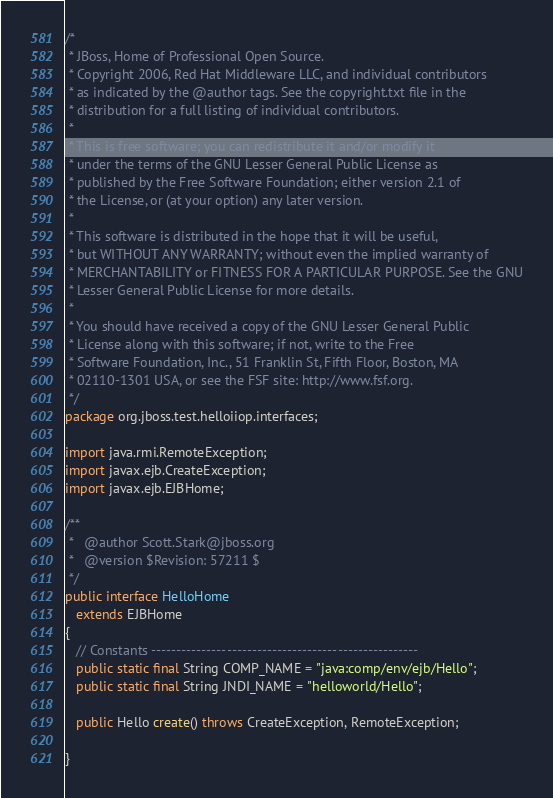Convert code to text. <code><loc_0><loc_0><loc_500><loc_500><_Java_>/*
 * JBoss, Home of Professional Open Source.
 * Copyright 2006, Red Hat Middleware LLC, and individual contributors
 * as indicated by the @author tags. See the copyright.txt file in the
 * distribution for a full listing of individual contributors.
 *
 * This is free software; you can redistribute it and/or modify it
 * under the terms of the GNU Lesser General Public License as
 * published by the Free Software Foundation; either version 2.1 of
 * the License, or (at your option) any later version.
 *
 * This software is distributed in the hope that it will be useful,
 * but WITHOUT ANY WARRANTY; without even the implied warranty of
 * MERCHANTABILITY or FITNESS FOR A PARTICULAR PURPOSE. See the GNU
 * Lesser General Public License for more details.
 *
 * You should have received a copy of the GNU Lesser General Public
 * License along with this software; if not, write to the Free
 * Software Foundation, Inc., 51 Franklin St, Fifth Floor, Boston, MA
 * 02110-1301 USA, or see the FSF site: http://www.fsf.org.
 */
package org.jboss.test.helloiiop.interfaces;

import java.rmi.RemoteException;
import javax.ejb.CreateException;
import javax.ejb.EJBHome;

/**
 *   @author Scott.Stark@jboss.org
 *   @version $Revision: 57211 $
 */
public interface HelloHome
   extends EJBHome
{
   // Constants -----------------------------------------------------
   public static final String COMP_NAME = "java:comp/env/ejb/Hello";
   public static final String JNDI_NAME = "helloworld/Hello";

   public Hello create() throws CreateException, RemoteException;
   
}
</code> 